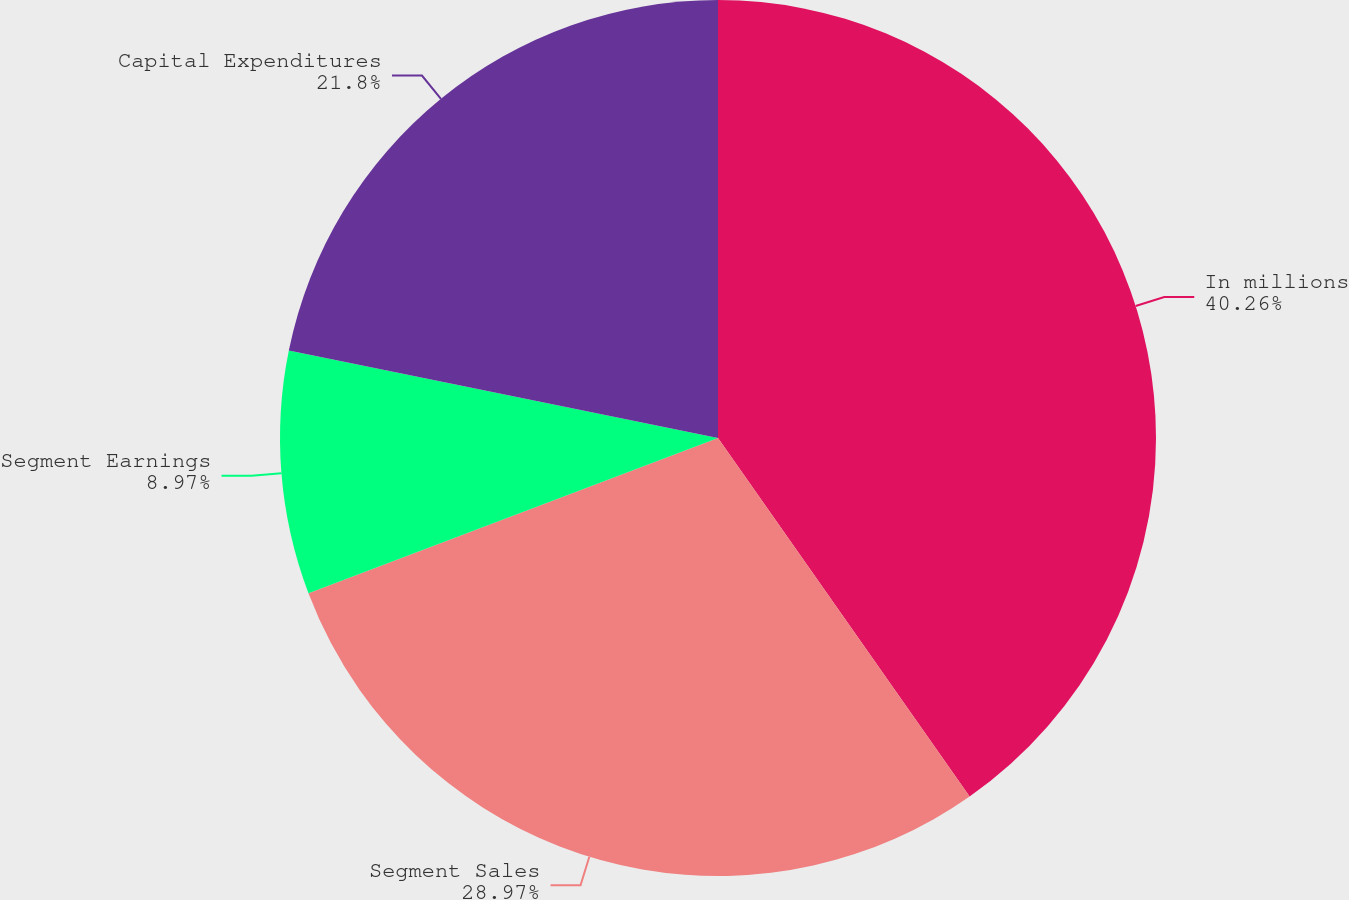<chart> <loc_0><loc_0><loc_500><loc_500><pie_chart><fcel>In millions<fcel>Segment Sales<fcel>Segment Earnings<fcel>Capital Expenditures<nl><fcel>40.26%<fcel>28.97%<fcel>8.97%<fcel>21.8%<nl></chart> 